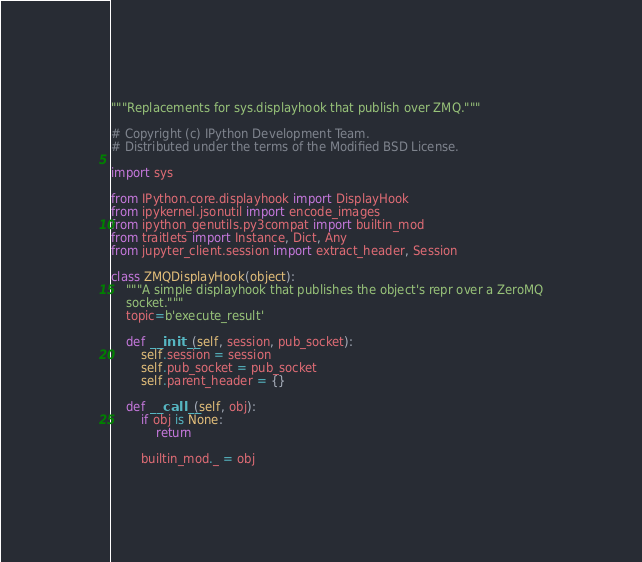<code> <loc_0><loc_0><loc_500><loc_500><_Python_>"""Replacements for sys.displayhook that publish over ZMQ."""

# Copyright (c) IPython Development Team.
# Distributed under the terms of the Modified BSD License.

import sys

from IPython.core.displayhook import DisplayHook
from ipykernel.jsonutil import encode_images
from ipython_genutils.py3compat import builtin_mod
from traitlets import Instance, Dict, Any
from jupyter_client.session import extract_header, Session

class ZMQDisplayHook(object):
    """A simple displayhook that publishes the object's repr over a ZeroMQ
    socket."""
    topic=b'execute_result'

    def __init__(self, session, pub_socket):
        self.session = session
        self.pub_socket = pub_socket
        self.parent_header = {}

    def __call__(self, obj):
        if obj is None:
            return

        builtin_mod._ = obj</code> 